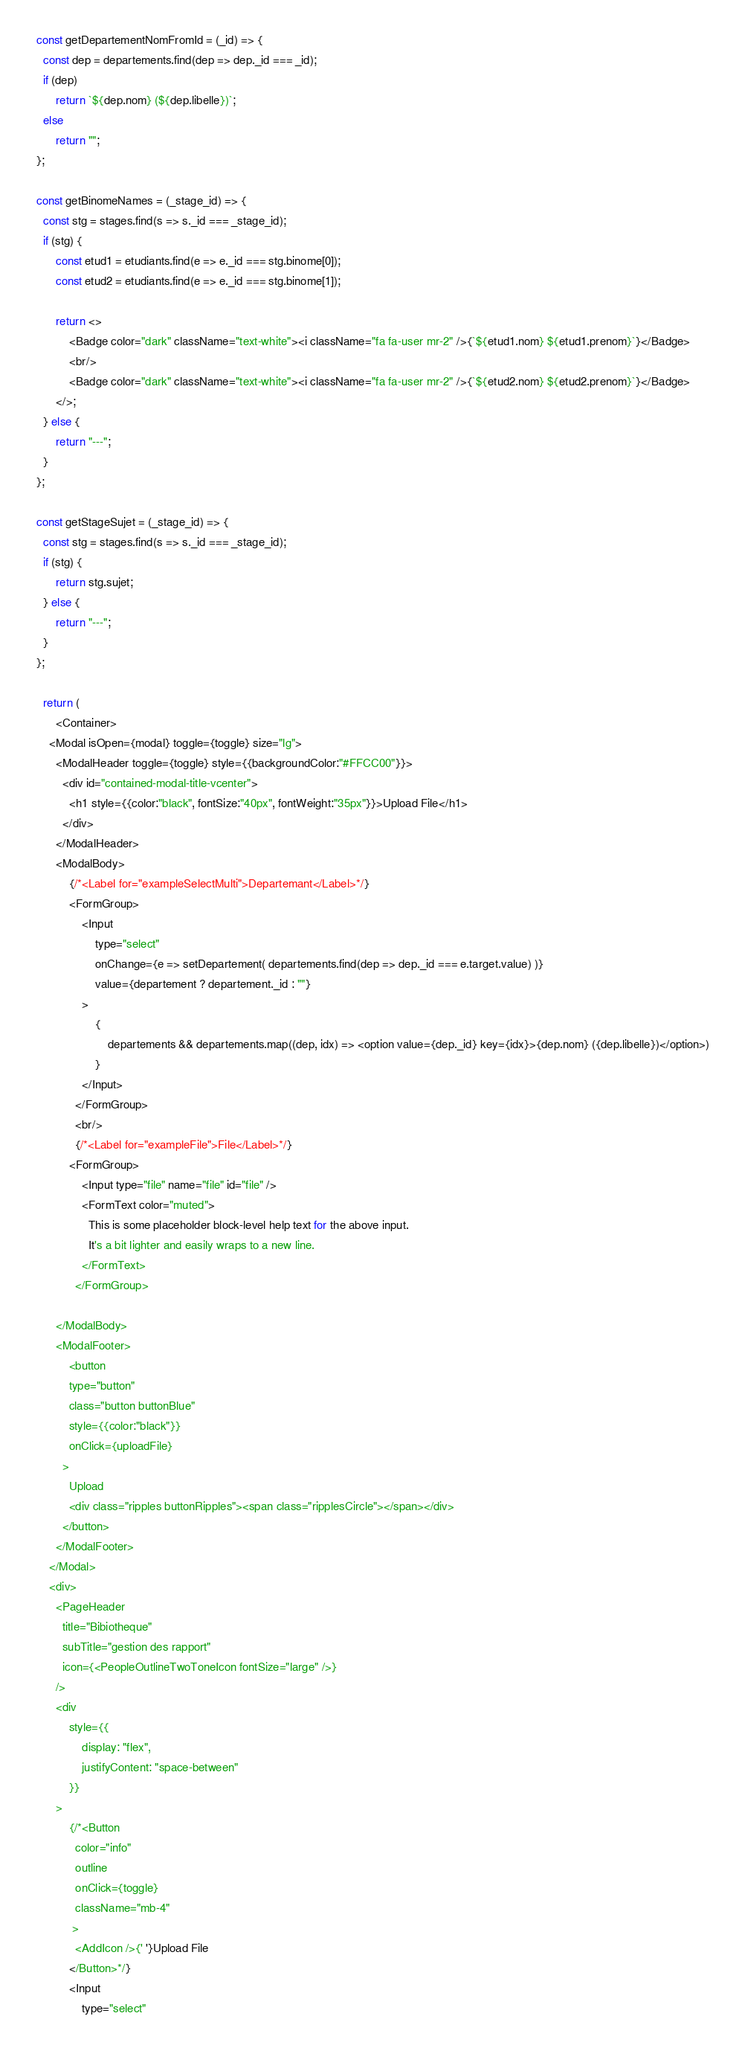<code> <loc_0><loc_0><loc_500><loc_500><_JavaScript_>
  const getDepartementNomFromId = (_id) => {
  	const dep = departements.find(dep => dep._id === _id);
  	if (dep)
  		return `${dep.nom} (${dep.libelle})`;
  	else 
  		return "";
  };

  const getBinomeNames = (_stage_id) => {
  	const stg = stages.find(s => s._id === _stage_id);
  	if (stg) {
  		const etud1 = etudiants.find(e => e._id === stg.binome[0]);
  		const etud2 = etudiants.find(e => e._id === stg.binome[1]);

  		return <>
  			<Badge color="dark" className="text-white"><i className="fa fa-user mr-2" />{`${etud1.nom} ${etud1.prenom}`}</Badge>
  			<br/>
  			<Badge color="dark" className="text-white"><i className="fa fa-user mr-2" />{`${etud2.nom} ${etud2.prenom}`}</Badge>
  		</>;
  	} else {
  		return "---";
  	}
  };

  const getStageSujet = (_stage_id) => {
  	const stg = stages.find(s => s._id === _stage_id);
  	if (stg) {
  		return stg.sujet;
  	} else {
  		return "---";
  	}
  };

	return (
		<Container>
      <Modal isOpen={modal} toggle={toggle} size="lg">
        <ModalHeader toggle={toggle} style={{backgroundColor:"#FFCC00"}}>
          <div id="contained-modal-title-vcenter">
            <h1 style={{color:"black", fontSize:"40px", fontWeight:"35px"}}>Upload File</h1>
          </div>
        </ModalHeader>
        <ModalBody>   
        	{/*<Label for="exampleSelectMulti">Departemant</Label>*/}
        	<FormGroup>
		        <Input 
		        	type="select" 
		        	onChange={e => setDepartement( departements.find(dep => dep._id === e.target.value) )} 
		        	value={departement ? departement._id : ""}
		        >
		        	{
		        		departements && departements.map((dep, idx) => <option value={dep._id} key={idx}>{dep.nom} ({dep.libelle})</option>)
		        	}
		        </Input>
		      </FormGroup>
		      <br/>
		      {/*<Label for="exampleFile">File</Label>*/}
        	<FormGroup>
		        <Input type="file" name="file" id="file" />
		        <FormText color="muted">
		          This is some placeholder block-level help text for the above input.
		          It's a bit lighter and easily wraps to a new line.
		        </FormText>
		      </FormGroup>

        </ModalBody>
        <ModalFooter>
        	<button
            type="button" 
            class="button buttonBlue" 
            style={{color:"black"}}
            onClick={uploadFile}
          >
            Upload
            <div class="ripples buttonRipples"><span class="ripplesCircle"></span></div>
          </button>
        </ModalFooter>
      </Modal>
      <div> 
        <PageHeader
          title="Bibiotheque"
          subTitle="gestion des rapport"
          icon={<PeopleOutlineTwoToneIcon fontSize="large" />}
        />
        <div
        	style={{
        		display: "flex",
        		justifyContent: "space-between"    	
        	}}
        >
        	{/*<Button
	          color="info"
	          outline
	          onClick={toggle}
	          className="mb-4"	        
	         >
	          <AddIcon />{' '}Upload File
	        </Button>*/}
	        <Input 
	        	type="select" </code> 